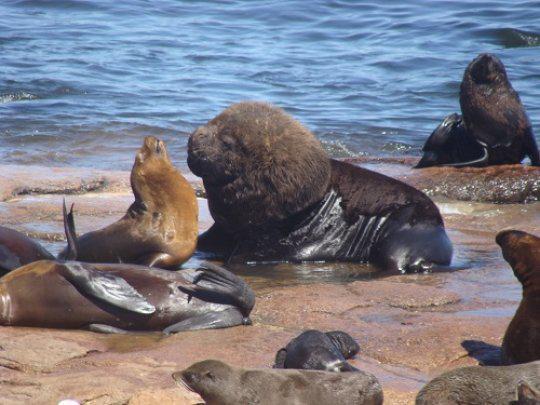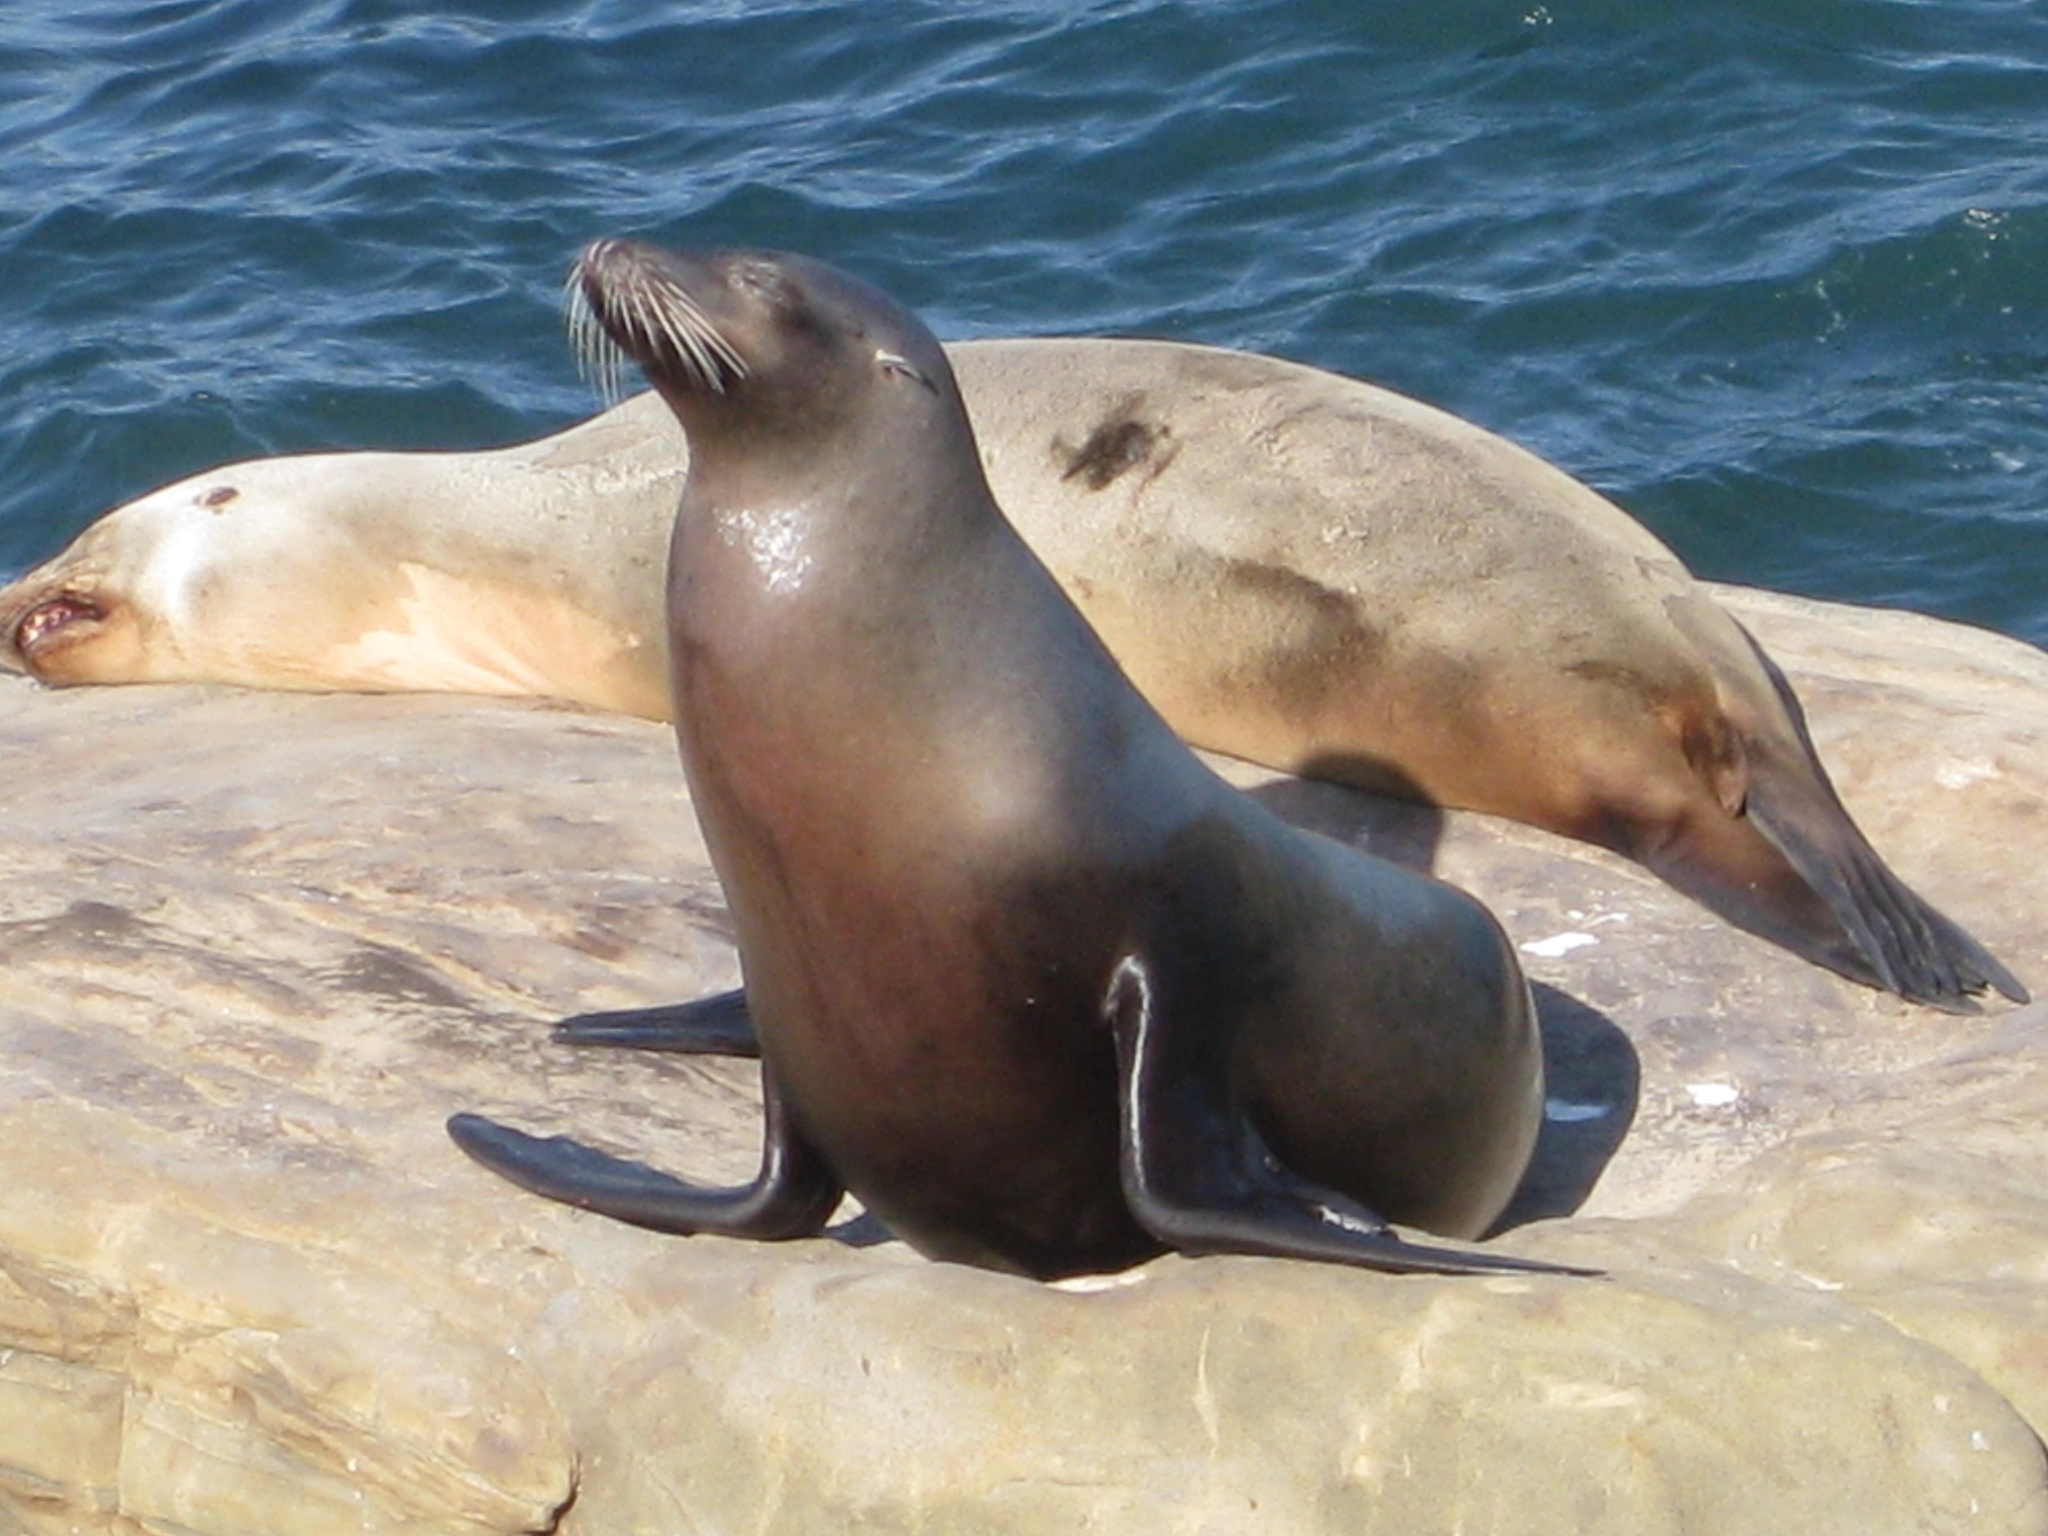The first image is the image on the left, the second image is the image on the right. Considering the images on both sides, is "One image includes a close-mouthed seal with its face poking up out of the water, and the other image includes multiple seals at the edge of water." valid? Answer yes or no. No. The first image is the image on the left, the second image is the image on the right. Evaluate the accuracy of this statement regarding the images: "The seals in the image on the right are sunning on a rock.". Is it true? Answer yes or no. Yes. 